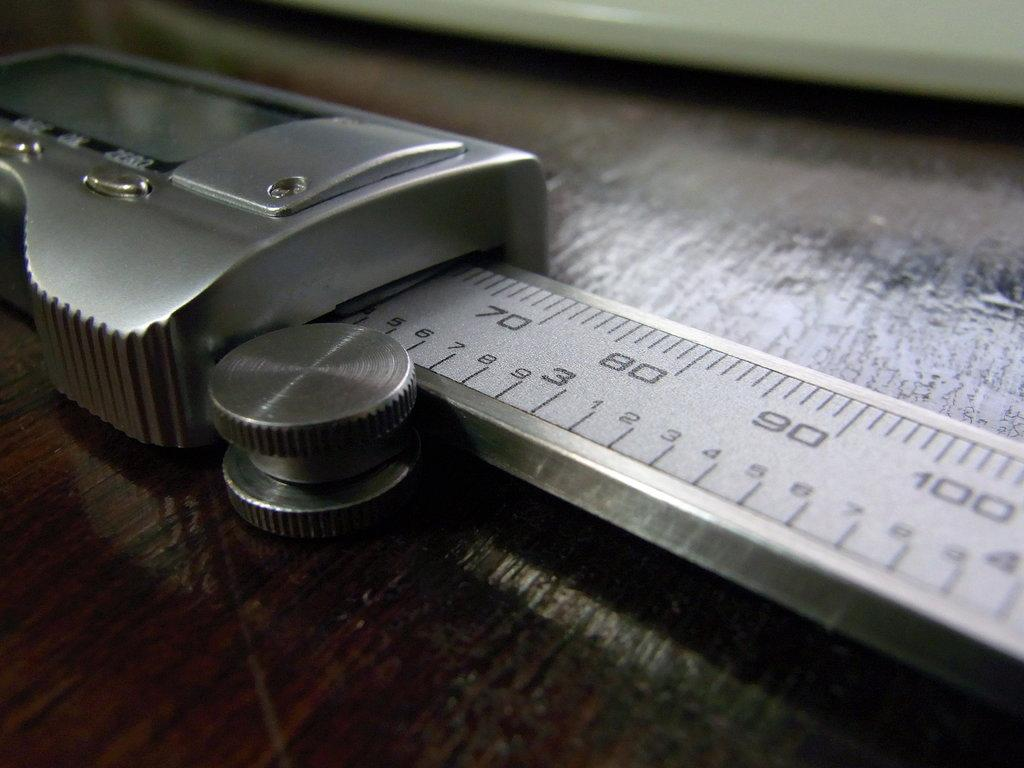<image>
Give a short and clear explanation of the subsequent image. One can see up to 100 milimetres on thsi metal measuring tape. 